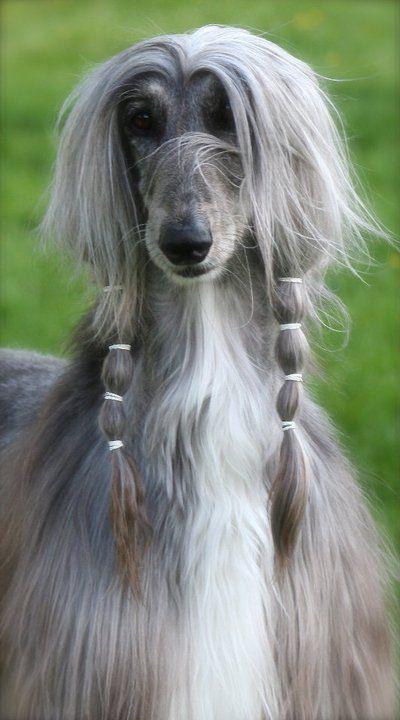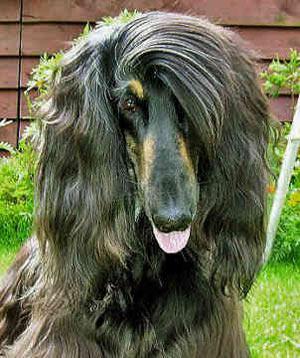The first image is the image on the left, the second image is the image on the right. Analyze the images presented: Is the assertion "One of the dogs has braided hair." valid? Answer yes or no. Yes. The first image is the image on the left, the second image is the image on the right. Assess this claim about the two images: "In at least one image there is a single dog with bangs the cover part of one eye.". Correct or not? Answer yes or no. Yes. 